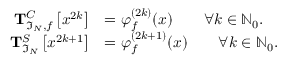Convert formula to latex. <formula><loc_0><loc_0><loc_500><loc_500>\begin{array} { r l } { T _ { \mathfrak { I } _ { N } , f } ^ { C } \left [ x ^ { 2 k } \right ] } & { = \varphi _ { f } ^ { ( 2 k ) } ( x ) \quad \forall k \in \mathbb { N } _ { 0 } . } \\ { T _ { \mathfrak { I } _ { N } } ^ { S } \left [ x ^ { 2 k + 1 } \right ] } & { = \varphi _ { f } ^ { ( 2 k + 1 ) } ( x ) \quad \forall k \in \mathbb { N } _ { 0 } . } \end{array}</formula> 